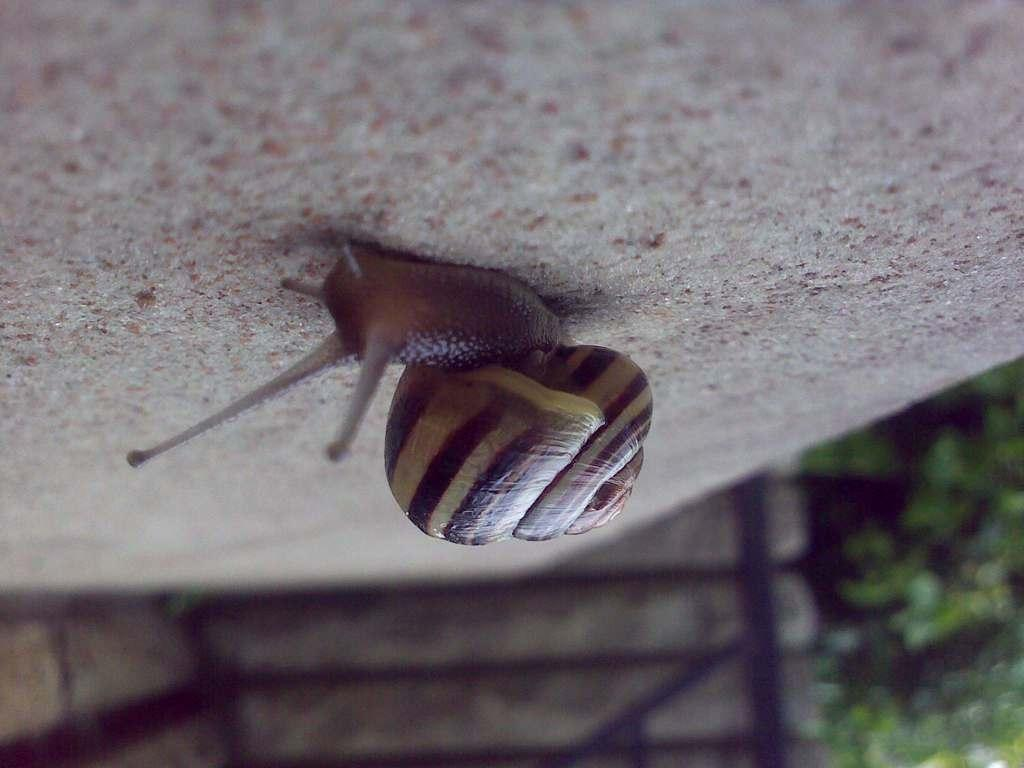What is the main subject of the image? There is a snail in the image. Where is the snail located? The snail is on the floor. What can be seen in the background of the image? There is a fence and greenery visible in the background of the image. What type of playground equipment can be seen in the image? There is no playground equipment present in the image; it features a snail on the floor with a fence and greenery in the background. 